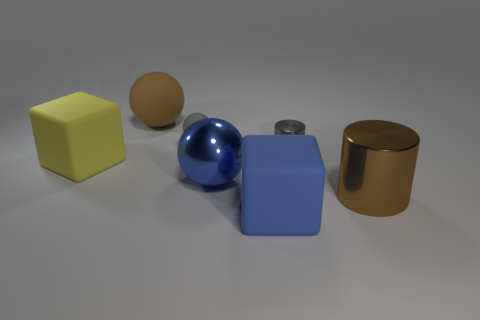There is a big brown thing that is behind the large cylinder; are there any large metallic things that are in front of it? Yes, in front of the large brown cylinder, there appears to be a smaller cylindrical object with a metallic surface, possibly a metal cap or lid. 